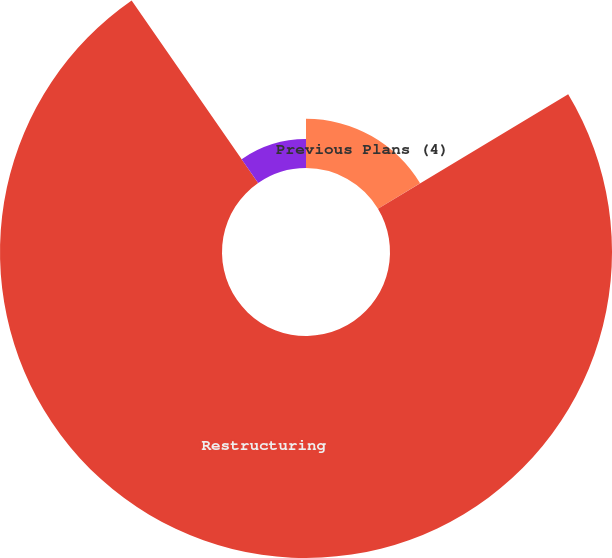Convert chart. <chart><loc_0><loc_0><loc_500><loc_500><pie_chart><fcel>Previous Plans (4)<fcel>Restructuring<fcel>Contract Termination<nl><fcel>16.38%<fcel>73.98%<fcel>9.65%<nl></chart> 